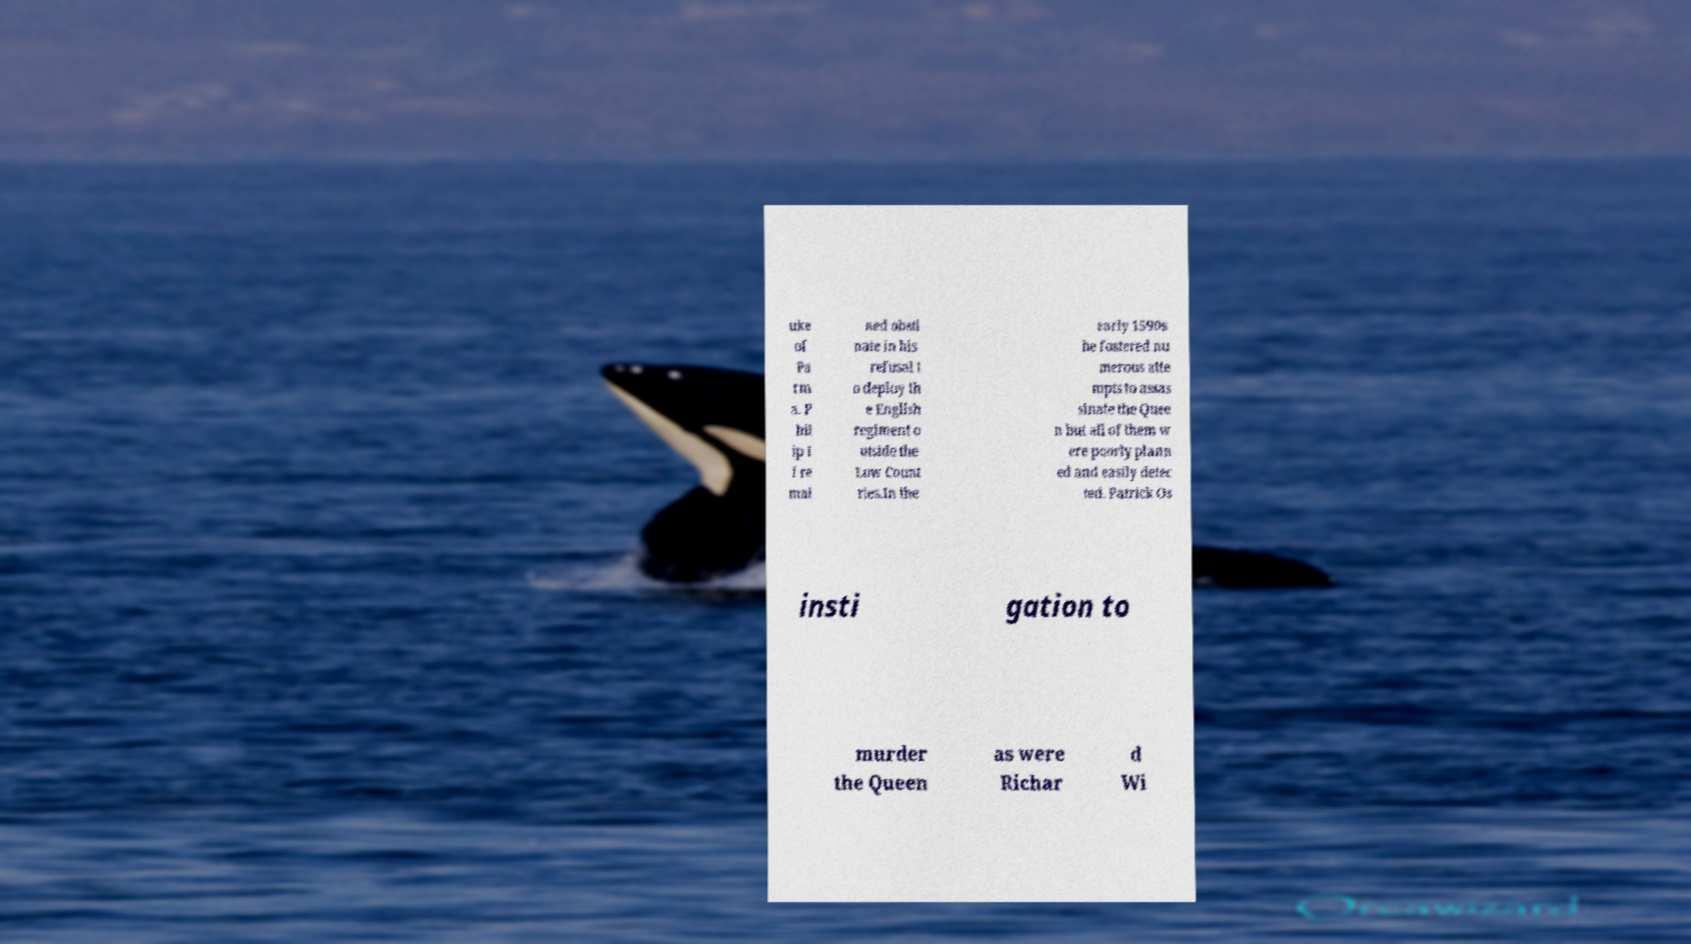What messages or text are displayed in this image? I need them in a readable, typed format. uke of Pa rm a. P hil ip I I re mai ned obsti nate in his refusal t o deploy th e English regiment o utside the Low Count ries.In the early 1590s he fostered nu merous atte mpts to assas sinate the Quee n but all of them w ere poorly plann ed and easily detec ted. Patrick Os insti gation to murder the Queen as were Richar d Wi 